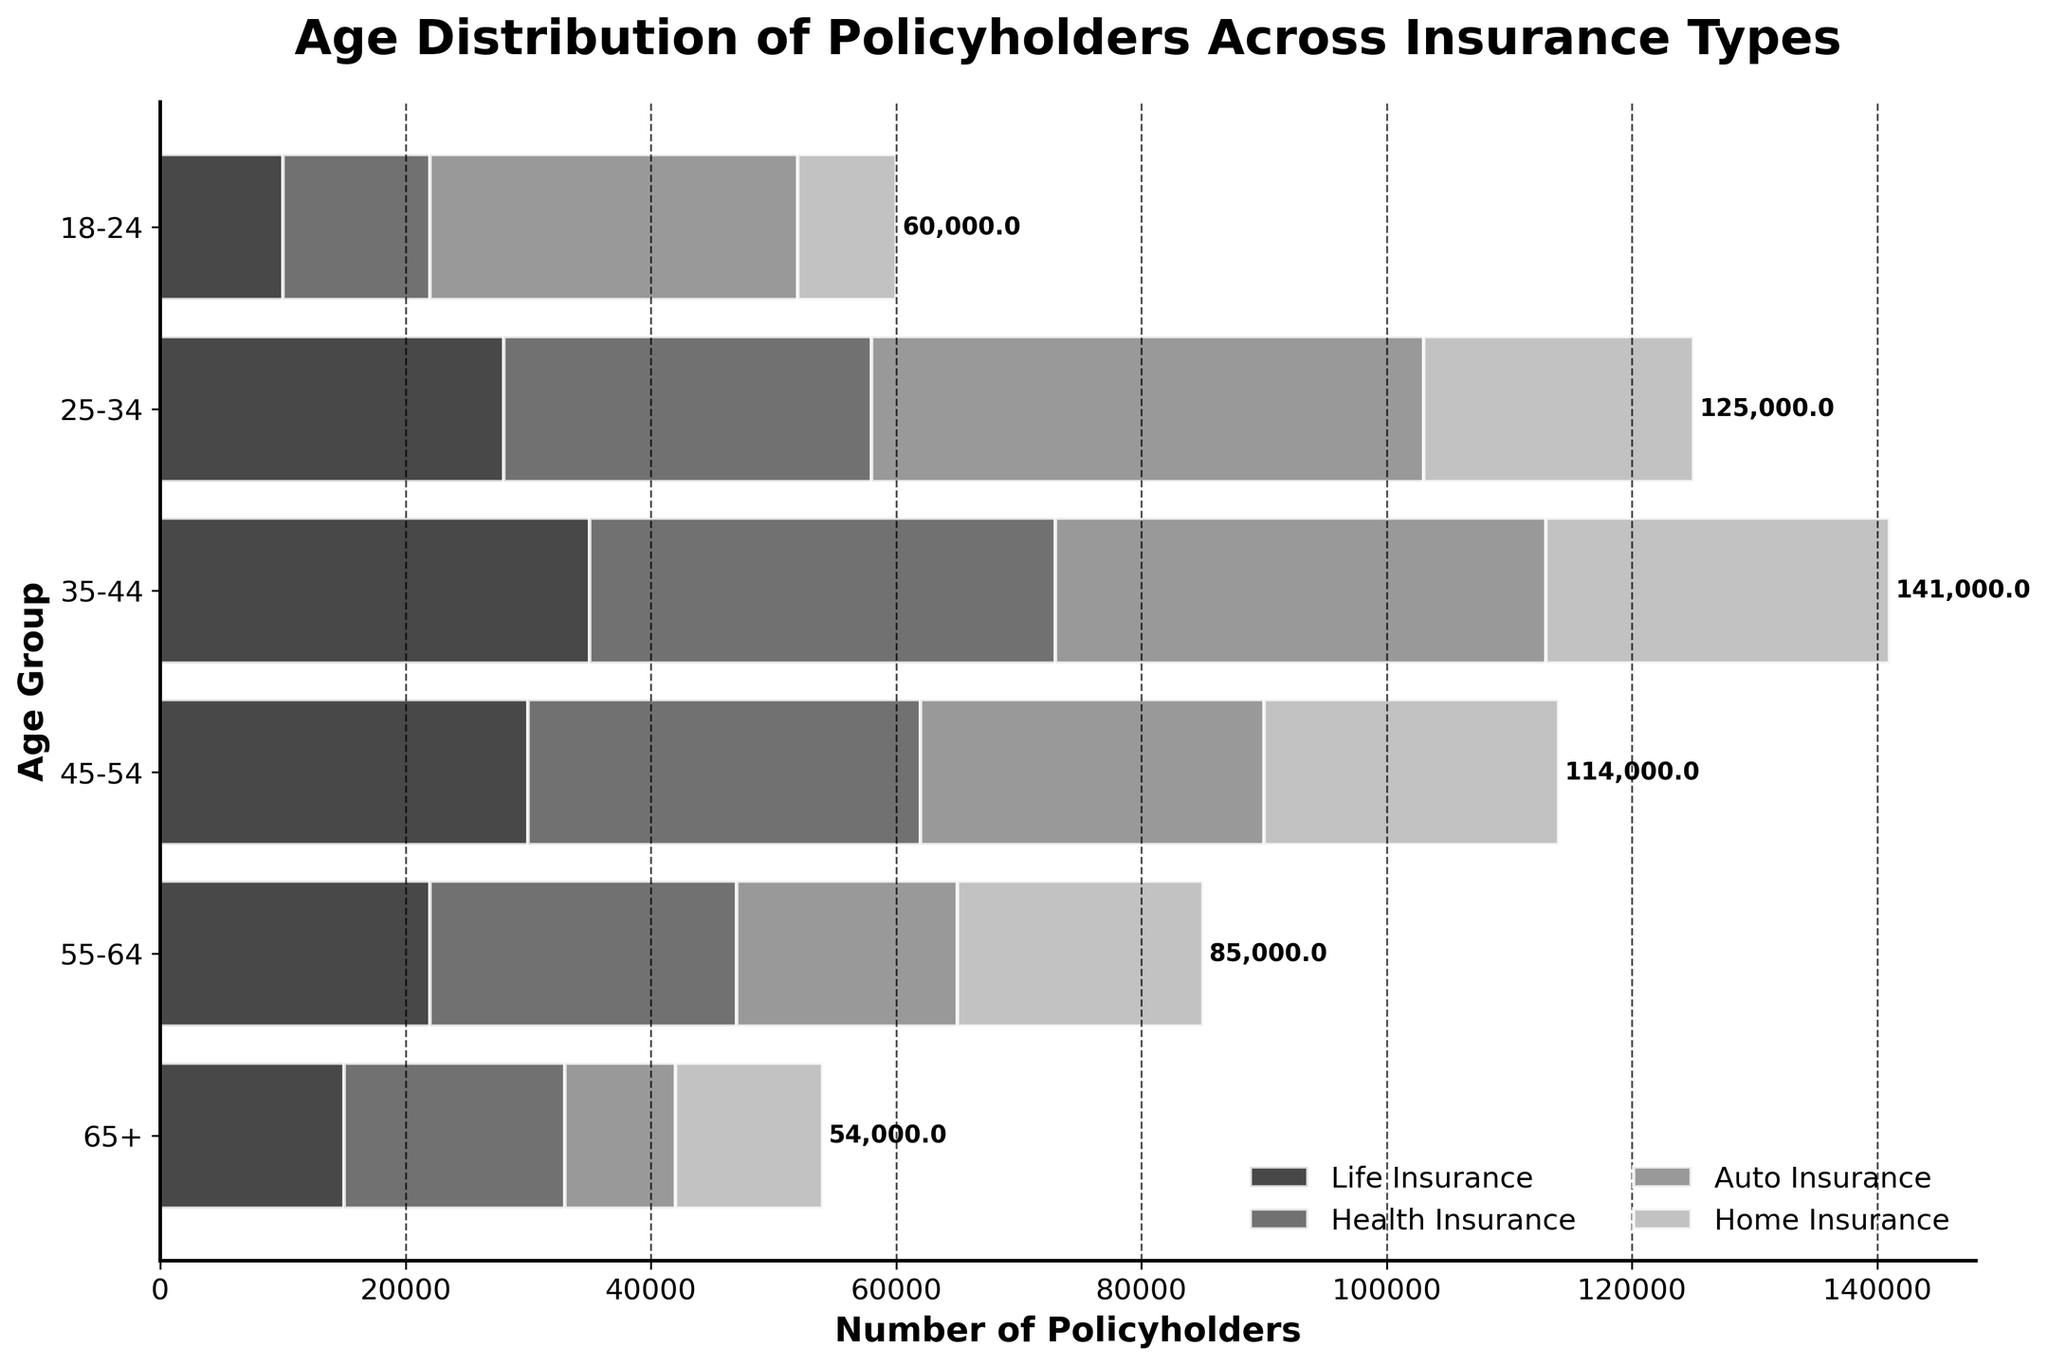What is the title of the figure? The title is prominently displayed at the top part of the figure.
Answer: Age Distribution of Policyholders Across Insurance Types Which age group has the highest number of life insurance policyholders? By looking at the bars representing life insurance for each age group, the 35-44 group has the longest bar.
Answer: 35-44 How many policyholders are in the 45-54 age group for auto insurance? The bar for auto insurance in the 45-54 age group ends at 28,000, as indicated by the horizontal axis.
Answer: 28,000 What's the total number of policyholders in the 55-64 age group across all insurance types? Sum the values for the 55-64 age group: Life Insurance (22,000) + Health Insurance (25,000) + Auto Insurance (18,000) + Home Insurance (20,000). This gives 22,000 + 25,000 + 18,000 + 20,000 = 85,000.
Answer: 85,000 Which insurance type has the least number of policyholders in the 18-24 age group? Compare the lengths of bars within the 18-24 age group for each insurance type. The home insurance bar is shortest.
Answer: Home Insurance Which age group has the highest total number of insurance policyholders? Look at the cumulative lengths of all bars for each age group. The 35-44 age group has the highest total when stacking all insurance types.
Answer: 35-44 What is the difference in total number of policyholders between the 45-54 age group and the 18-24 age group? Calculate the totals for both groups: 45-54: (30,000 + 32,000 + 28,000 + 24,000) = 114,000, and 18-24: (10,000 + 12,000 + 30,000 + 8,000) = 60,000. Then, subtract the two: 114,000 - 60,000 = 54,000.
Answer: 54,000 Which age group shows a higher number of home insurance policyholders compared to others, except the 35-44 group? Compare the home insurance bars across age groups, excluding 35-44. The highest after 35-44 is 55-64.
Answer: 55-64 How many more policyholders in health insurance are there in the 35-44 age group compared to the 25-34 group? Subtract the number of health insurance policyholders in the 25-34 group (30,000) from the 35-44 group (38,000): 38,000 - 30,000 = 8,000.
Answer: 8,000 